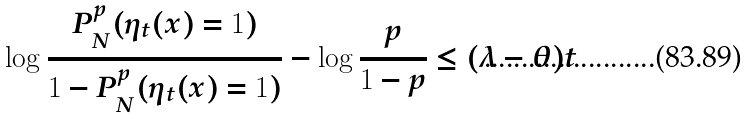Convert formula to latex. <formula><loc_0><loc_0><loc_500><loc_500>\log \frac { P _ { N } ^ { p } ( \eta _ { t } ( x ) = 1 ) } { 1 - P _ { N } ^ { p } ( \eta _ { t } ( x ) = 1 ) } - \log \frac { p } { 1 - p } \leq ( \lambda - \theta ) t</formula> 